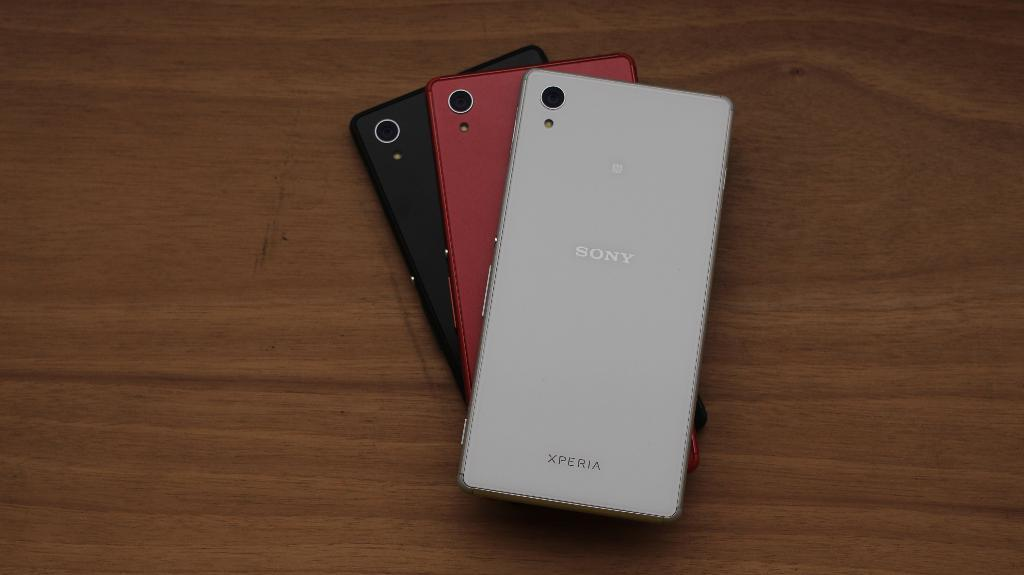<image>
Summarize the visual content of the image. The brand name of the silver phone is "Sony." 